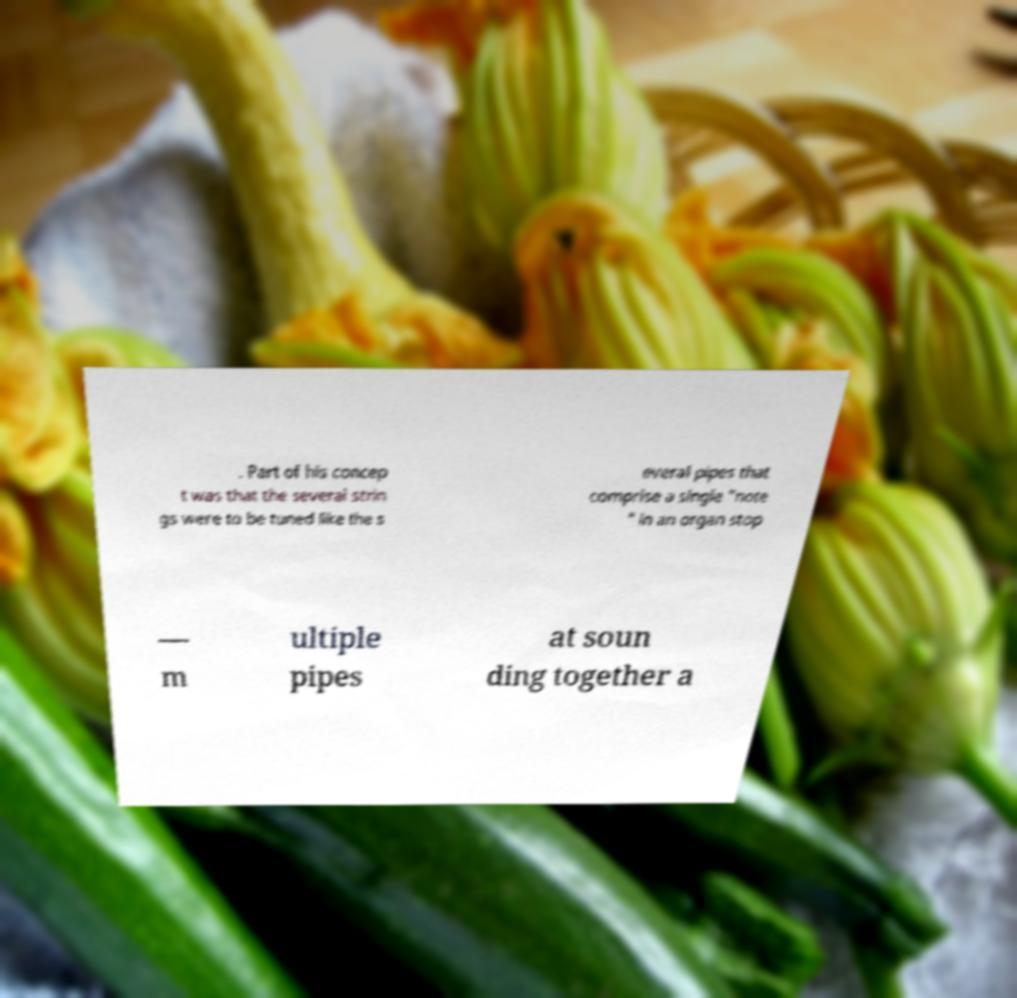I need the written content from this picture converted into text. Can you do that? . Part of his concep t was that the several strin gs were to be tuned like the s everal pipes that comprise a single "note " in an organ stop — m ultiple pipes at soun ding together a 